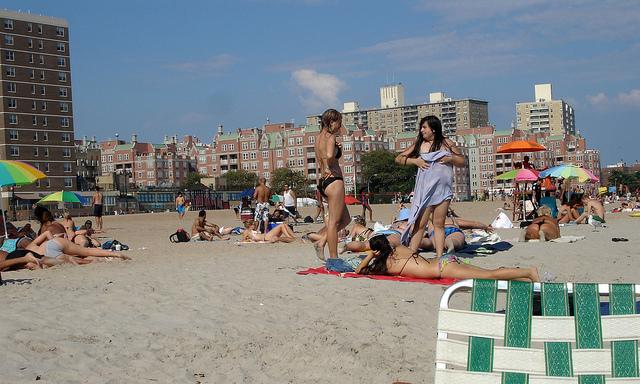The person under the orange umbrella is whom?

Choices:
A) dog walker
B) police officer
C) queen
D) life guard life guard 